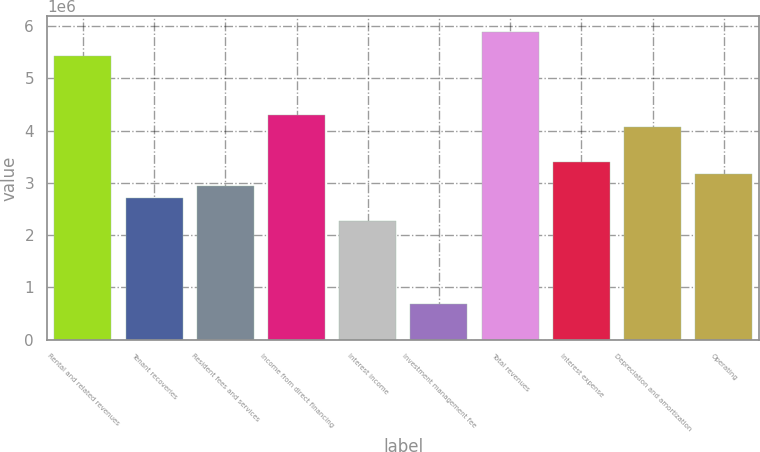Convert chart to OTSL. <chart><loc_0><loc_0><loc_500><loc_500><bar_chart><fcel>Rental and related revenues<fcel>Tenant recoveries<fcel>Resident fees and services<fcel>Income from direct financing<fcel>Interest income<fcel>Investment management fee<fcel>Total revenues<fcel>Interest expense<fcel>Depreciation and amortization<fcel>Operating<nl><fcel>5.43907e+06<fcel>2.71953e+06<fcel>2.94616e+06<fcel>4.30593e+06<fcel>2.26628e+06<fcel>679884<fcel>5.89233e+06<fcel>3.39942e+06<fcel>4.0793e+06<fcel>3.17279e+06<nl></chart> 